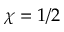Convert formula to latex. <formula><loc_0><loc_0><loc_500><loc_500>\chi = 1 / 2</formula> 